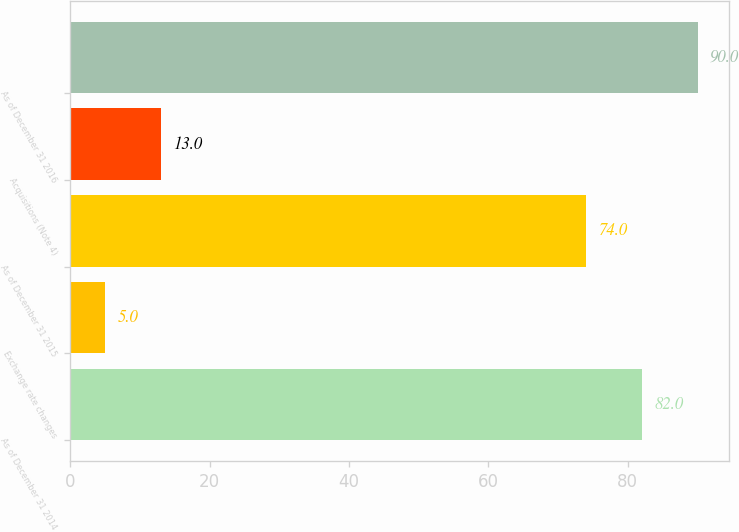Convert chart to OTSL. <chart><loc_0><loc_0><loc_500><loc_500><bar_chart><fcel>As of December 31 2014<fcel>Exchange rate changes<fcel>As of December 31 2015<fcel>Acquisitions (Note 4)<fcel>As of December 31 2016<nl><fcel>82<fcel>5<fcel>74<fcel>13<fcel>90<nl></chart> 